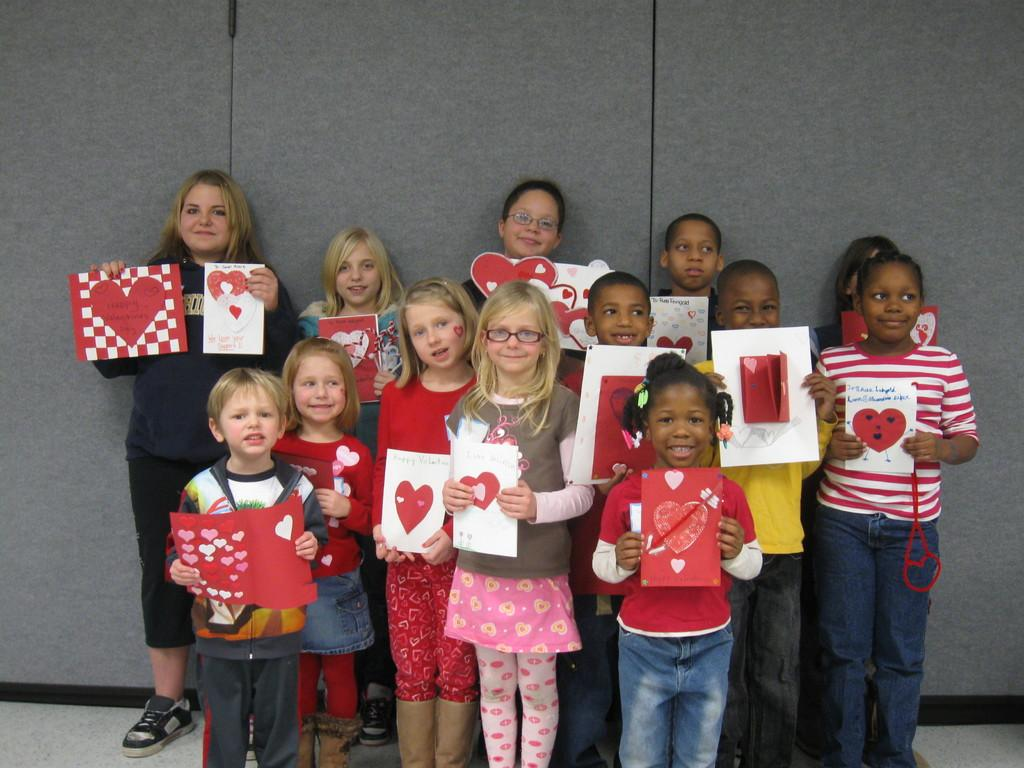What can be seen in the image? There are children in the image. What are the children holding? The children are holding greeting cards. Where are the children standing? The children are standing on the floor. What is the facial expression of the children? The children are smiling. What are the children doing in the image? The children are posing for the picture. What is visible in the background of the image? There is a wall in the background of the image. What is the purpose of the spot on the floor in the image? There is no spot on the floor mentioned in the image, so it cannot be determined what its purpose might be. 